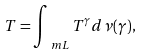Convert formula to latex. <formula><loc_0><loc_0><loc_500><loc_500>T = \int _ { \ m L } T ^ { \gamma } d \nu ( \gamma ) ,</formula> 